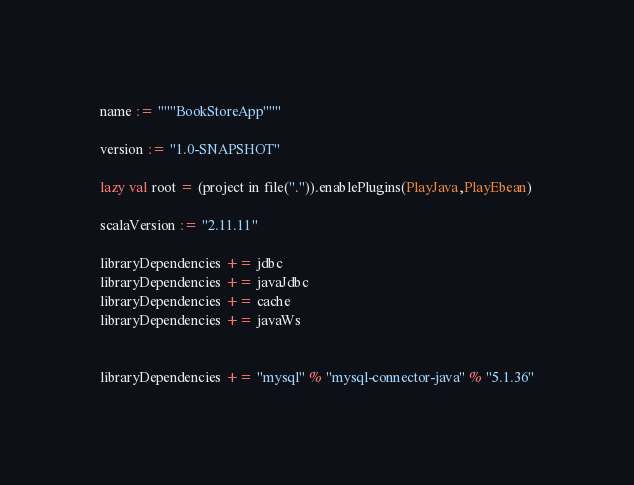Convert code to text. <code><loc_0><loc_0><loc_500><loc_500><_Scala_>name := """BookStoreApp"""

version := "1.0-SNAPSHOT"

lazy val root = (project in file(".")).enablePlugins(PlayJava,PlayEbean)

scalaVersion := "2.11.11"

libraryDependencies += jdbc
libraryDependencies += javaJdbc
libraryDependencies += cache
libraryDependencies += javaWs


libraryDependencies += "mysql" % "mysql-connector-java" % "5.1.36"</code> 